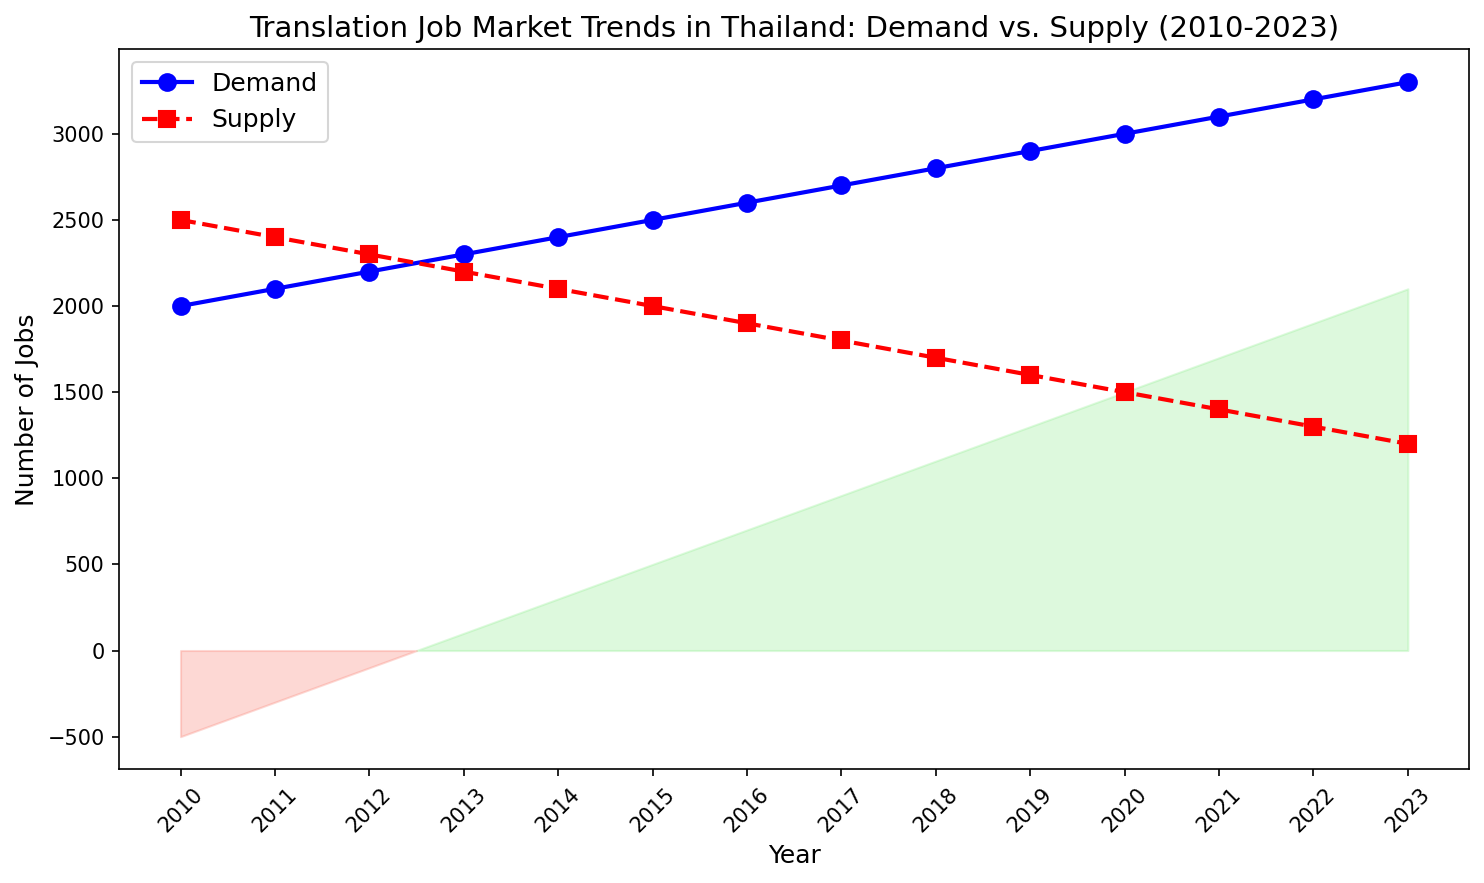What is the overall trend observed in the demand for translation jobs in Thailand from 2010 to 2023? The line chart shows an increasing trend in the demand for translation jobs, starting at 2000 in 2010 and rising steadily to 3300 in 2023.
Answer: Increasing trend How does the supply of translation jobs in 2015 compare to 2020? In 2015, the supply of translation jobs is 2000, while in 2020, it decreases to 1500.
Answer: The supply in 2015 is higher than in 2020 What is the difference between demand and supply for translation jobs in the year 2023? In 2023, the demand is 3300, and the supply is 1200. The difference is calculated as 3300 - 1200 = 2100.
Answer: 2100 During which year was the gap between demand and supply for translation jobs the smallest? The gap is smallest in 2010, where demand is 2000 and supply is 2500. The difference is 500. This is the smallest gap compared to other years.
Answer: 2010 In how many years does the supply of translation jobs fall below 2000? The supply falls below 2000 from 2016 onwards, which includes the years 2016, 2017, 2018, 2019, 2020, 2021, 2022, and 2023. This totals 8 years.
Answer: 8 years Is there any year when the difference between demand and supply is negative? The chart indicates that the area between the lines is filled with salmon color where the supply exceeds demand. However, from 2010 to 2023, the demand is higher than supply in all years, resulting in no negative difference.
Answer: No What is the average demand for translation jobs over the entire period? Sum the annual demands from 2010 to 2023 and divide by the number of years. The sum is (2000 + 2100 + 2200 + 2300 + 2400 + 2500 + 2600 + 2700 + 2800 + 2900 + 3000 + 3100 + 3200 + 3300) = 40100, divided by 14 years is approximately 2864.
Answer: 2864 What color is used to represent the area where the difference between demand and supply is positive? The chart fills the positive difference area with a light green color.
Answer: Light green What is the largest difference between demand and supply observed in the chart, and in which year does it occur? The largest difference is in 2023, where demand is 3300 and supply is 1200. The difference is 3300 - 1200 = 2100.
Answer: 2100 in 2023 In which years does the supply of translation jobs equal exactly 1900? According to the chart, the supply equals 1900 in the year 2016.
Answer: 2016 